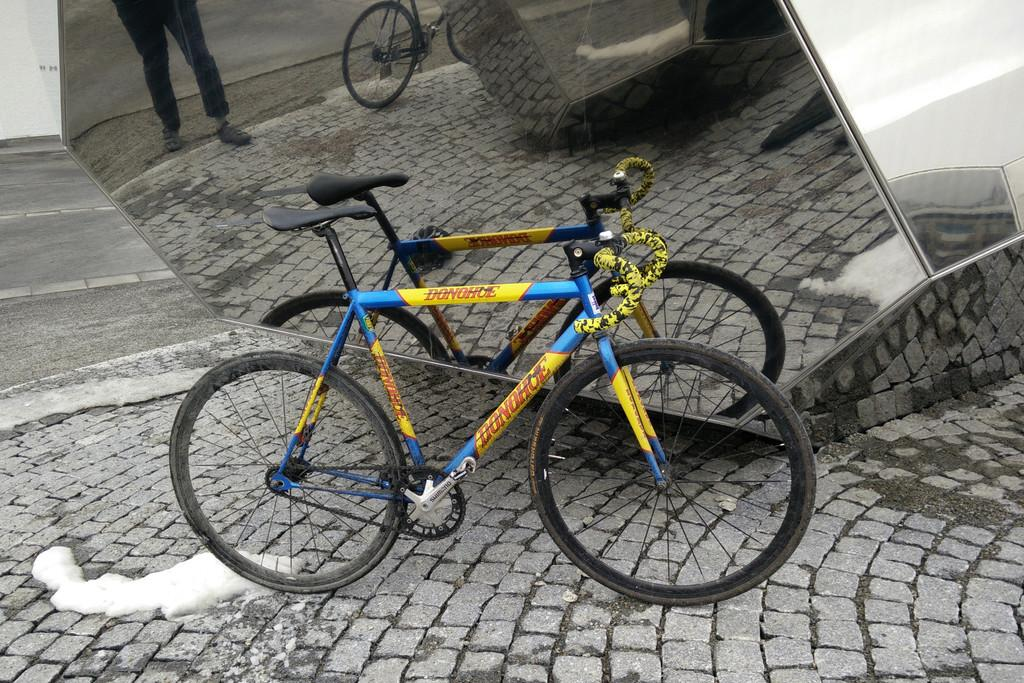What is the main object in the image? There is a cycle in the image. What is located near the cycle? There is a mirror near the cycle. What can be seen in the mirror? The reflection of the cycle and legs of a person are visible in the mirror. What is the setting of the image? There is a road in the image. Can you tell me how many cherries are on the cycle in the image? There are no cherries present on the cycle or in the image. What type of woman is riding the cycle in the image? There is no woman riding the cycle in the image; only the reflection of a person's legs can be seen in the mirror. 